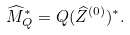Convert formula to latex. <formula><loc_0><loc_0><loc_500><loc_500>\widehat { M } ^ { * } _ { Q } = Q ( \widehat { Z } ^ { ( 0 ) } ) ^ { * } .</formula> 